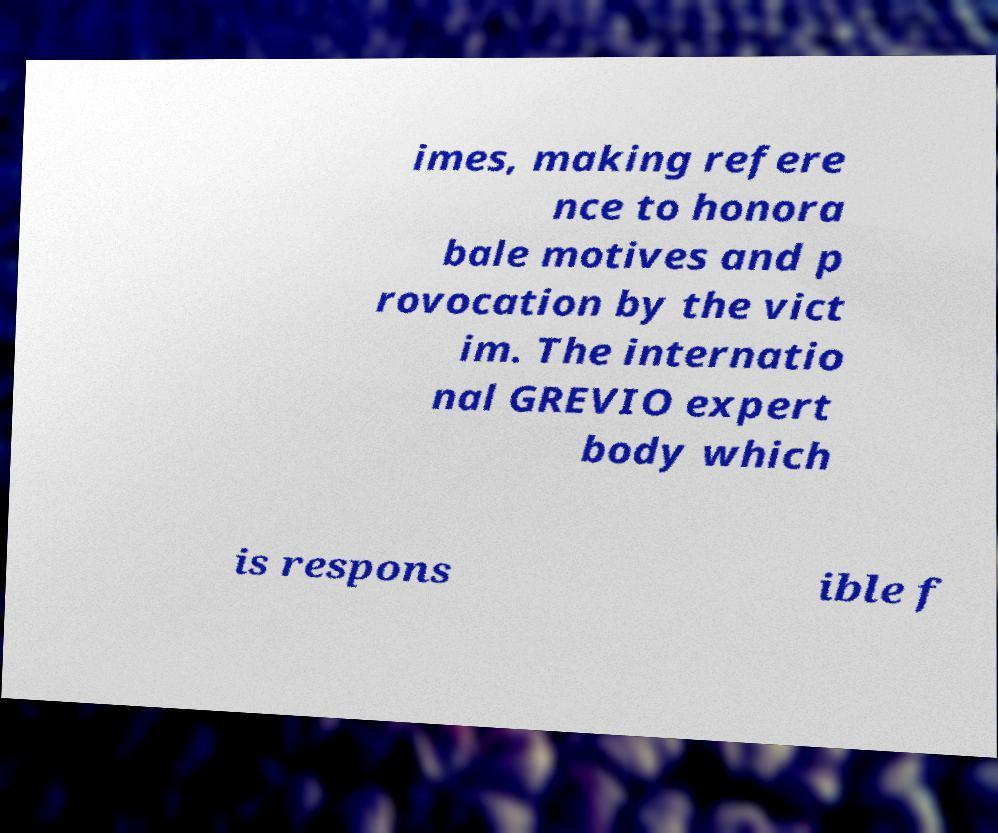For documentation purposes, I need the text within this image transcribed. Could you provide that? imes, making refere nce to honora bale motives and p rovocation by the vict im. The internatio nal GREVIO expert body which is respons ible f 